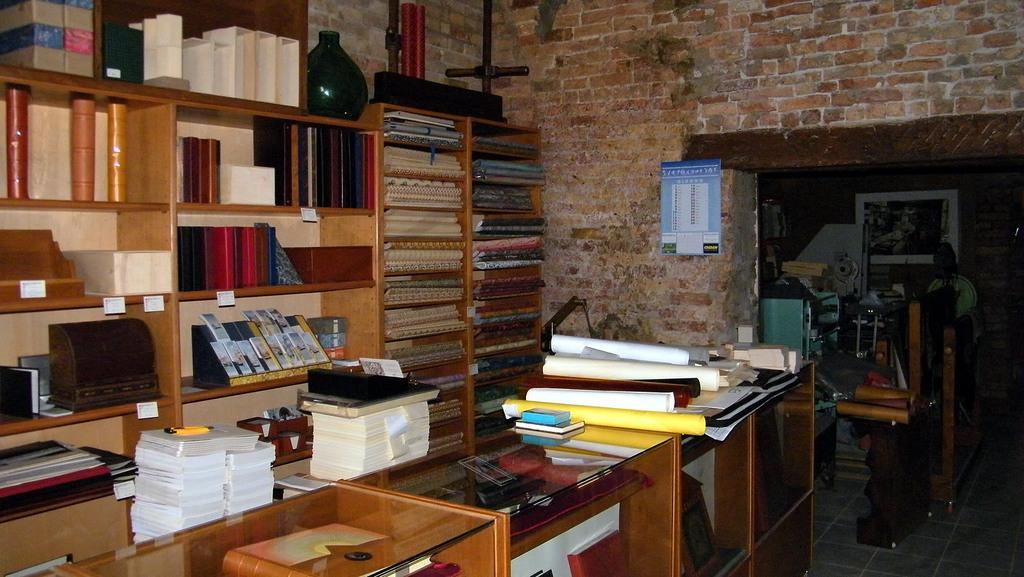Please provide a concise description of this image. In this image we can see a group of charts, books and papers placed on the tables. We can also see a group of books, a vase, metal poles, a device and a cardboard box which are placed in the shelves and a calendar on a wall. On the right side we can see a refrigerator and some objects on the surface and a board on a wall. 